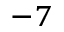<formula> <loc_0><loc_0><loc_500><loc_500>^ { - 7 }</formula> 